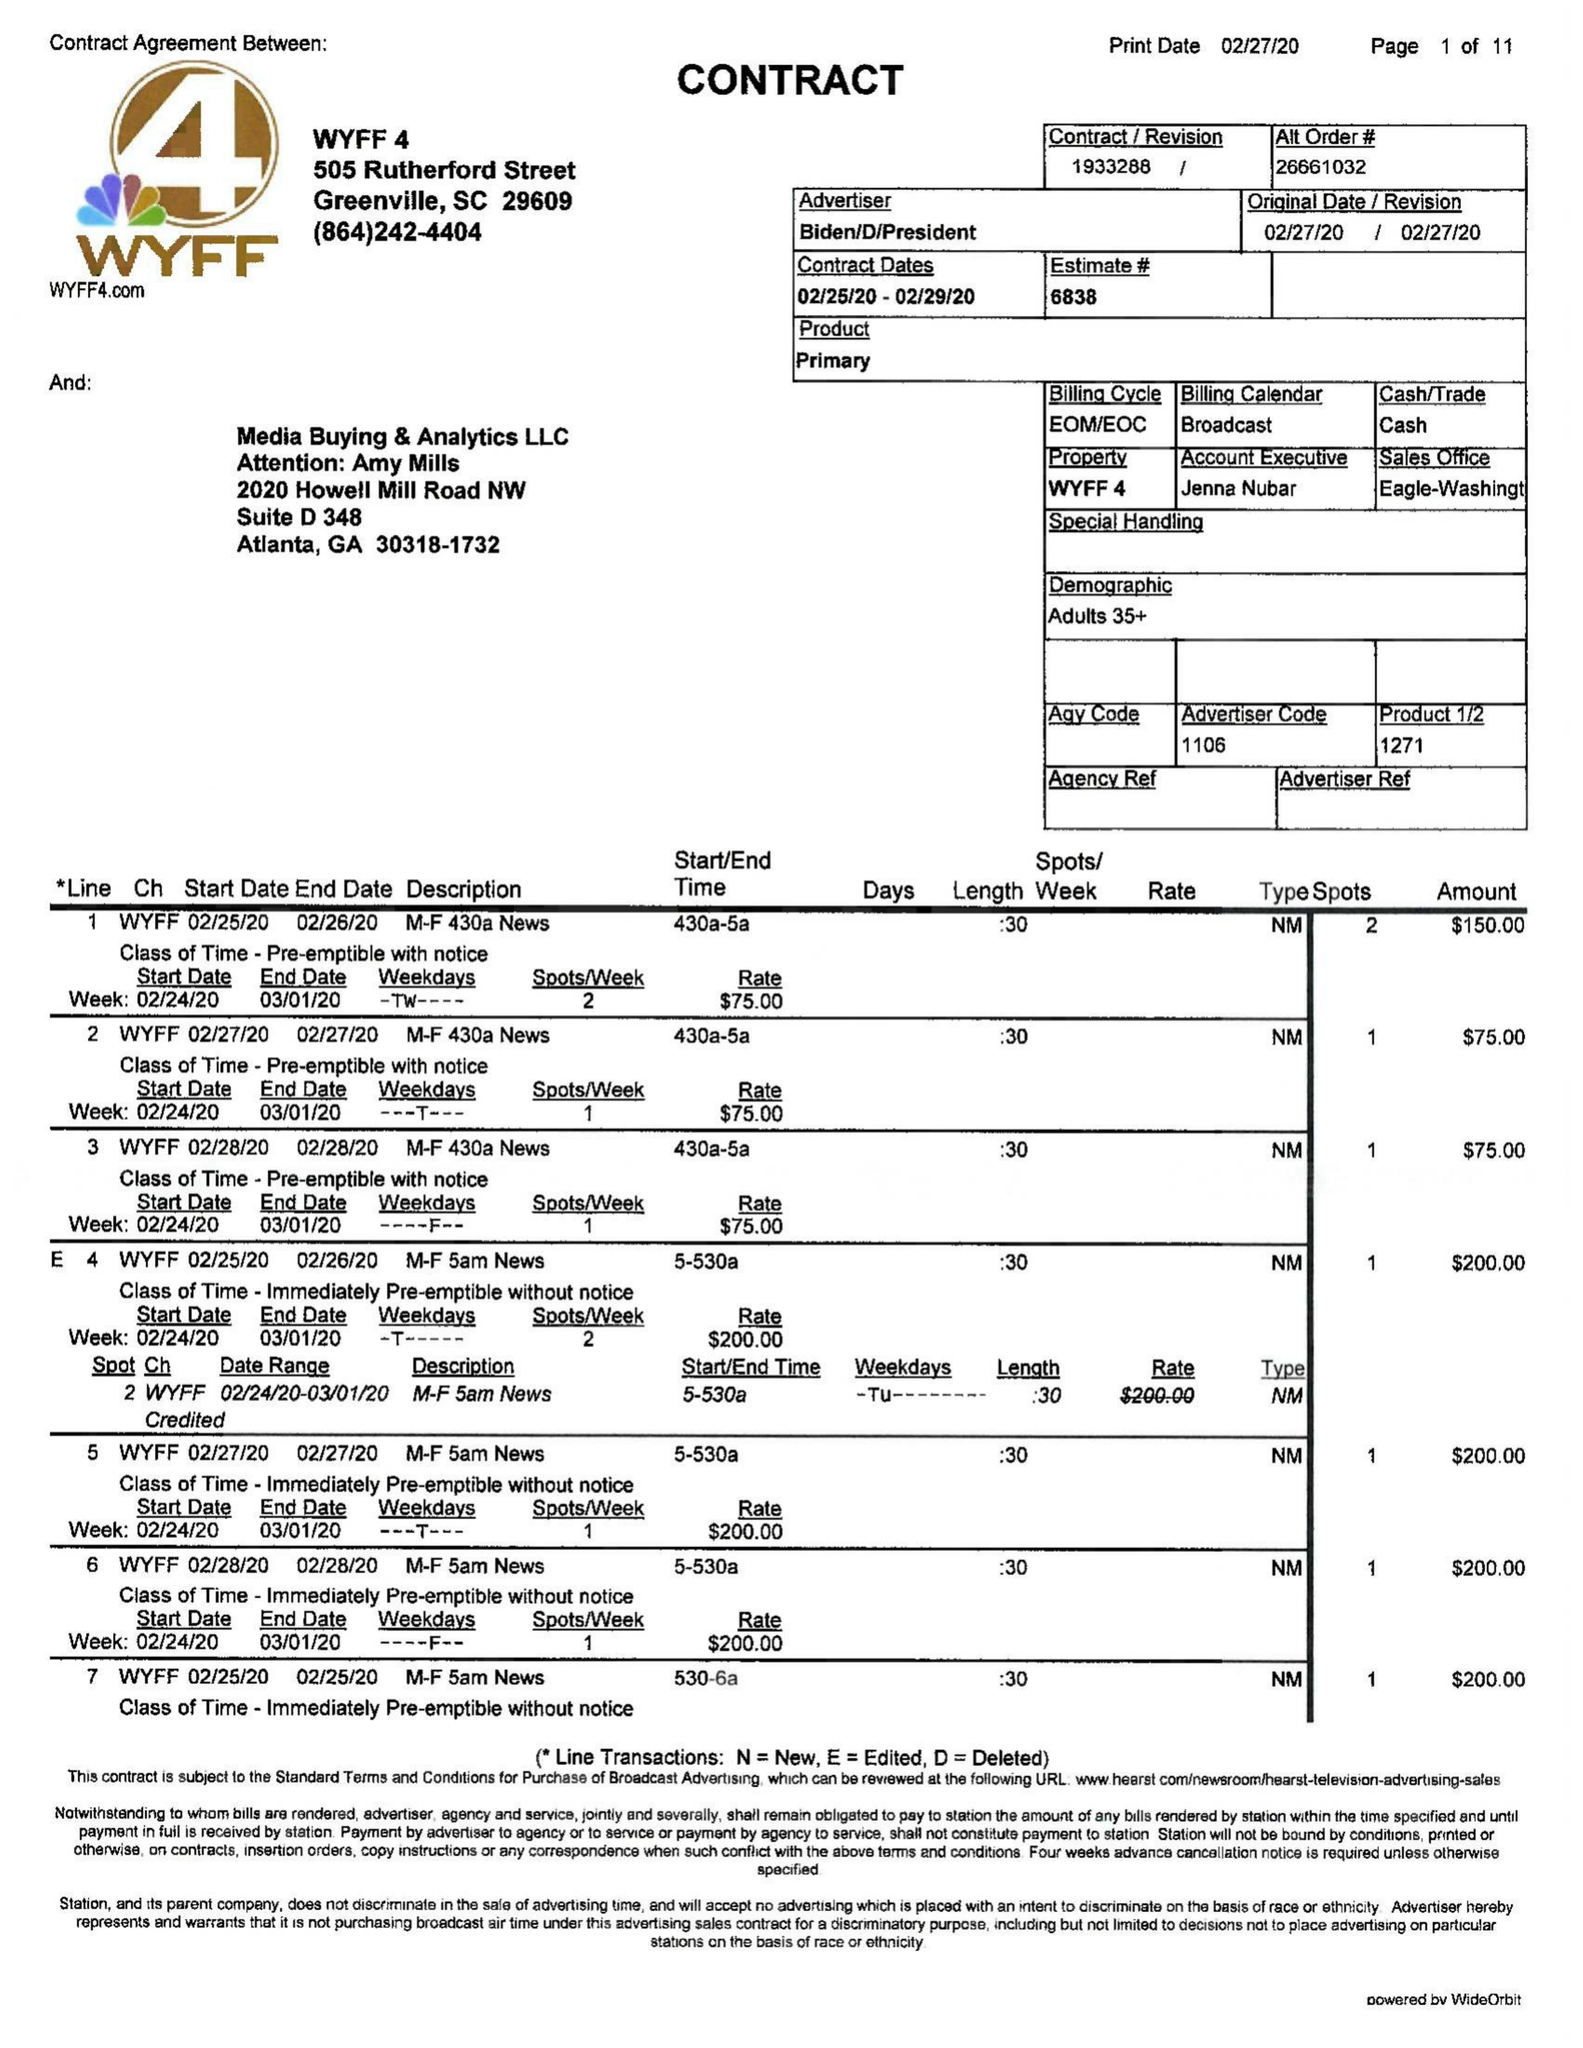What is the value for the flight_from?
Answer the question using a single word or phrase. 02/24/20 